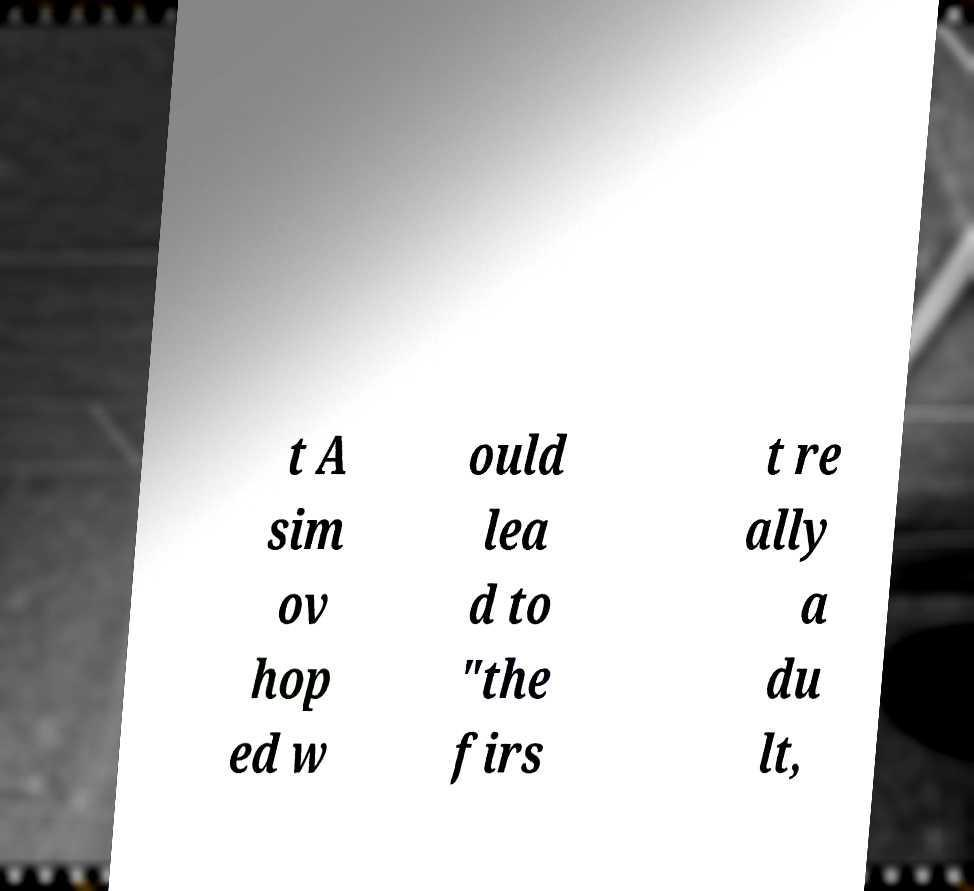For documentation purposes, I need the text within this image transcribed. Could you provide that? t A sim ov hop ed w ould lea d to "the firs t re ally a du lt, 